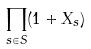<formula> <loc_0><loc_0><loc_500><loc_500>\prod _ { s \in S } ( 1 + X _ { s } )</formula> 